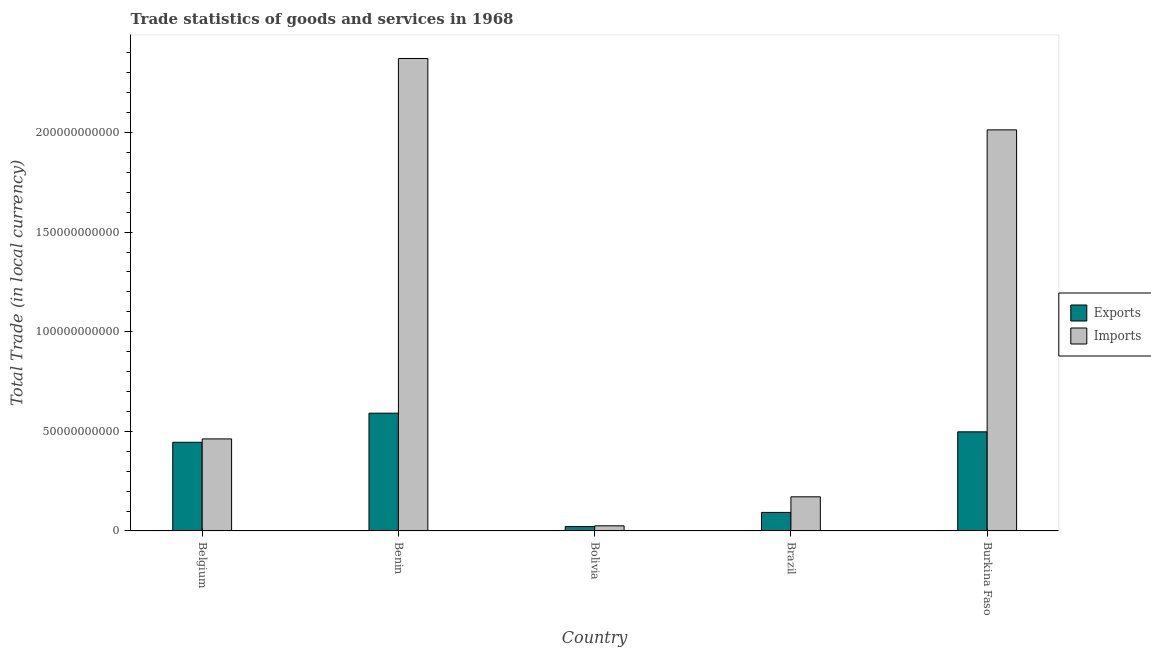How many groups of bars are there?
Give a very brief answer. 5. Are the number of bars per tick equal to the number of legend labels?
Your response must be concise. Yes. Are the number of bars on each tick of the X-axis equal?
Your response must be concise. Yes. How many bars are there on the 1st tick from the right?
Ensure brevity in your answer.  2. What is the label of the 5th group of bars from the left?
Your answer should be very brief. Burkina Faso. In how many cases, is the number of bars for a given country not equal to the number of legend labels?
Give a very brief answer. 0. What is the export of goods and services in Belgium?
Keep it short and to the point. 4.45e+1. Across all countries, what is the maximum imports of goods and services?
Make the answer very short. 2.37e+11. Across all countries, what is the minimum imports of goods and services?
Provide a short and direct response. 2.57e+09. In which country was the export of goods and services maximum?
Provide a succinct answer. Benin. In which country was the imports of goods and services minimum?
Provide a succinct answer. Bolivia. What is the total export of goods and services in the graph?
Give a very brief answer. 1.65e+11. What is the difference between the export of goods and services in Benin and that in Burkina Faso?
Provide a succinct answer. 9.37e+09. What is the difference between the export of goods and services in Brazil and the imports of goods and services in Belgium?
Provide a short and direct response. -3.69e+1. What is the average export of goods and services per country?
Keep it short and to the point. 3.30e+1. What is the difference between the export of goods and services and imports of goods and services in Bolivia?
Your answer should be very brief. -3.64e+08. What is the ratio of the imports of goods and services in Benin to that in Brazil?
Give a very brief answer. 13.84. Is the export of goods and services in Bolivia less than that in Burkina Faso?
Give a very brief answer. Yes. What is the difference between the highest and the second highest export of goods and services?
Provide a short and direct response. 9.37e+09. What is the difference between the highest and the lowest imports of goods and services?
Your answer should be compact. 2.35e+11. Is the sum of the imports of goods and services in Belgium and Burkina Faso greater than the maximum export of goods and services across all countries?
Your response must be concise. Yes. What does the 2nd bar from the left in Benin represents?
Provide a succinct answer. Imports. What does the 1st bar from the right in Burkina Faso represents?
Give a very brief answer. Imports. How many bars are there?
Give a very brief answer. 10. Are all the bars in the graph horizontal?
Provide a short and direct response. No. How many countries are there in the graph?
Ensure brevity in your answer.  5. What is the difference between two consecutive major ticks on the Y-axis?
Provide a short and direct response. 5.00e+1. Are the values on the major ticks of Y-axis written in scientific E-notation?
Your answer should be very brief. No. Does the graph contain grids?
Keep it short and to the point. No. How many legend labels are there?
Provide a short and direct response. 2. How are the legend labels stacked?
Provide a succinct answer. Vertical. What is the title of the graph?
Keep it short and to the point. Trade statistics of goods and services in 1968. What is the label or title of the X-axis?
Make the answer very short. Country. What is the label or title of the Y-axis?
Keep it short and to the point. Total Trade (in local currency). What is the Total Trade (in local currency) of Exports in Belgium?
Give a very brief answer. 4.45e+1. What is the Total Trade (in local currency) in Imports in Belgium?
Provide a succinct answer. 4.62e+1. What is the Total Trade (in local currency) in Exports in Benin?
Ensure brevity in your answer.  5.91e+1. What is the Total Trade (in local currency) of Imports in Benin?
Your response must be concise. 2.37e+11. What is the Total Trade (in local currency) in Exports in Bolivia?
Offer a very short reply. 2.20e+09. What is the Total Trade (in local currency) of Imports in Bolivia?
Offer a very short reply. 2.57e+09. What is the Total Trade (in local currency) in Exports in Brazil?
Offer a very short reply. 9.30e+09. What is the Total Trade (in local currency) of Imports in Brazil?
Provide a short and direct response. 1.71e+1. What is the Total Trade (in local currency) in Exports in Burkina Faso?
Your answer should be compact. 4.97e+1. What is the Total Trade (in local currency) in Imports in Burkina Faso?
Ensure brevity in your answer.  2.01e+11. Across all countries, what is the maximum Total Trade (in local currency) in Exports?
Offer a terse response. 5.91e+1. Across all countries, what is the maximum Total Trade (in local currency) in Imports?
Ensure brevity in your answer.  2.37e+11. Across all countries, what is the minimum Total Trade (in local currency) in Exports?
Your response must be concise. 2.20e+09. Across all countries, what is the minimum Total Trade (in local currency) of Imports?
Your answer should be compact. 2.57e+09. What is the total Total Trade (in local currency) of Exports in the graph?
Give a very brief answer. 1.65e+11. What is the total Total Trade (in local currency) of Imports in the graph?
Offer a terse response. 5.04e+11. What is the difference between the Total Trade (in local currency) in Exports in Belgium and that in Benin?
Offer a very short reply. -1.46e+1. What is the difference between the Total Trade (in local currency) of Imports in Belgium and that in Benin?
Offer a terse response. -1.91e+11. What is the difference between the Total Trade (in local currency) in Exports in Belgium and that in Bolivia?
Ensure brevity in your answer.  4.23e+1. What is the difference between the Total Trade (in local currency) in Imports in Belgium and that in Bolivia?
Your answer should be very brief. 4.36e+1. What is the difference between the Total Trade (in local currency) in Exports in Belgium and that in Brazil?
Make the answer very short. 3.52e+1. What is the difference between the Total Trade (in local currency) in Imports in Belgium and that in Brazil?
Your answer should be very brief. 2.91e+1. What is the difference between the Total Trade (in local currency) of Exports in Belgium and that in Burkina Faso?
Provide a succinct answer. -5.25e+09. What is the difference between the Total Trade (in local currency) in Imports in Belgium and that in Burkina Faso?
Ensure brevity in your answer.  -1.55e+11. What is the difference between the Total Trade (in local currency) of Exports in Benin and that in Bolivia?
Your answer should be compact. 5.69e+1. What is the difference between the Total Trade (in local currency) in Imports in Benin and that in Bolivia?
Provide a short and direct response. 2.35e+11. What is the difference between the Total Trade (in local currency) in Exports in Benin and that in Brazil?
Provide a succinct answer. 4.98e+1. What is the difference between the Total Trade (in local currency) of Imports in Benin and that in Brazil?
Keep it short and to the point. 2.20e+11. What is the difference between the Total Trade (in local currency) in Exports in Benin and that in Burkina Faso?
Provide a short and direct response. 9.37e+09. What is the difference between the Total Trade (in local currency) in Imports in Benin and that in Burkina Faso?
Make the answer very short. 3.58e+1. What is the difference between the Total Trade (in local currency) of Exports in Bolivia and that in Brazil?
Offer a terse response. -7.09e+09. What is the difference between the Total Trade (in local currency) of Imports in Bolivia and that in Brazil?
Provide a short and direct response. -1.46e+1. What is the difference between the Total Trade (in local currency) of Exports in Bolivia and that in Burkina Faso?
Make the answer very short. -4.75e+1. What is the difference between the Total Trade (in local currency) in Imports in Bolivia and that in Burkina Faso?
Provide a succinct answer. -1.99e+11. What is the difference between the Total Trade (in local currency) in Exports in Brazil and that in Burkina Faso?
Your answer should be compact. -4.05e+1. What is the difference between the Total Trade (in local currency) in Imports in Brazil and that in Burkina Faso?
Provide a short and direct response. -1.84e+11. What is the difference between the Total Trade (in local currency) in Exports in Belgium and the Total Trade (in local currency) in Imports in Benin?
Your answer should be very brief. -1.93e+11. What is the difference between the Total Trade (in local currency) in Exports in Belgium and the Total Trade (in local currency) in Imports in Bolivia?
Keep it short and to the point. 4.19e+1. What is the difference between the Total Trade (in local currency) in Exports in Belgium and the Total Trade (in local currency) in Imports in Brazil?
Ensure brevity in your answer.  2.74e+1. What is the difference between the Total Trade (in local currency) in Exports in Belgium and the Total Trade (in local currency) in Imports in Burkina Faso?
Provide a succinct answer. -1.57e+11. What is the difference between the Total Trade (in local currency) in Exports in Benin and the Total Trade (in local currency) in Imports in Bolivia?
Give a very brief answer. 5.66e+1. What is the difference between the Total Trade (in local currency) of Exports in Benin and the Total Trade (in local currency) of Imports in Brazil?
Offer a very short reply. 4.20e+1. What is the difference between the Total Trade (in local currency) of Exports in Benin and the Total Trade (in local currency) of Imports in Burkina Faso?
Give a very brief answer. -1.42e+11. What is the difference between the Total Trade (in local currency) in Exports in Bolivia and the Total Trade (in local currency) in Imports in Brazil?
Your answer should be very brief. -1.49e+1. What is the difference between the Total Trade (in local currency) in Exports in Bolivia and the Total Trade (in local currency) in Imports in Burkina Faso?
Make the answer very short. -1.99e+11. What is the difference between the Total Trade (in local currency) of Exports in Brazil and the Total Trade (in local currency) of Imports in Burkina Faso?
Offer a terse response. -1.92e+11. What is the average Total Trade (in local currency) in Exports per country?
Provide a short and direct response. 3.30e+1. What is the average Total Trade (in local currency) in Imports per country?
Provide a succinct answer. 1.01e+11. What is the difference between the Total Trade (in local currency) in Exports and Total Trade (in local currency) in Imports in Belgium?
Your response must be concise. -1.69e+09. What is the difference between the Total Trade (in local currency) in Exports and Total Trade (in local currency) in Imports in Benin?
Your answer should be compact. -1.78e+11. What is the difference between the Total Trade (in local currency) in Exports and Total Trade (in local currency) in Imports in Bolivia?
Give a very brief answer. -3.64e+08. What is the difference between the Total Trade (in local currency) of Exports and Total Trade (in local currency) of Imports in Brazil?
Offer a very short reply. -7.83e+09. What is the difference between the Total Trade (in local currency) of Exports and Total Trade (in local currency) of Imports in Burkina Faso?
Give a very brief answer. -1.52e+11. What is the ratio of the Total Trade (in local currency) of Exports in Belgium to that in Benin?
Make the answer very short. 0.75. What is the ratio of the Total Trade (in local currency) of Imports in Belgium to that in Benin?
Make the answer very short. 0.19. What is the ratio of the Total Trade (in local currency) of Exports in Belgium to that in Bolivia?
Give a very brief answer. 20.19. What is the ratio of the Total Trade (in local currency) of Imports in Belgium to that in Bolivia?
Make the answer very short. 17.99. What is the ratio of the Total Trade (in local currency) in Exports in Belgium to that in Brazil?
Offer a very short reply. 4.79. What is the ratio of the Total Trade (in local currency) in Imports in Belgium to that in Brazil?
Make the answer very short. 2.7. What is the ratio of the Total Trade (in local currency) in Exports in Belgium to that in Burkina Faso?
Offer a terse response. 0.89. What is the ratio of the Total Trade (in local currency) in Imports in Belgium to that in Burkina Faso?
Ensure brevity in your answer.  0.23. What is the ratio of the Total Trade (in local currency) of Exports in Benin to that in Bolivia?
Offer a terse response. 26.82. What is the ratio of the Total Trade (in local currency) in Imports in Benin to that in Bolivia?
Your response must be concise. 92.37. What is the ratio of the Total Trade (in local currency) of Exports in Benin to that in Brazil?
Offer a very short reply. 6.36. What is the ratio of the Total Trade (in local currency) in Imports in Benin to that in Brazil?
Offer a very short reply. 13.84. What is the ratio of the Total Trade (in local currency) of Exports in Benin to that in Burkina Faso?
Your response must be concise. 1.19. What is the ratio of the Total Trade (in local currency) of Imports in Benin to that in Burkina Faso?
Keep it short and to the point. 1.18. What is the ratio of the Total Trade (in local currency) in Exports in Bolivia to that in Brazil?
Your response must be concise. 0.24. What is the ratio of the Total Trade (in local currency) of Imports in Bolivia to that in Brazil?
Provide a short and direct response. 0.15. What is the ratio of the Total Trade (in local currency) of Exports in Bolivia to that in Burkina Faso?
Give a very brief answer. 0.04. What is the ratio of the Total Trade (in local currency) in Imports in Bolivia to that in Burkina Faso?
Provide a succinct answer. 0.01. What is the ratio of the Total Trade (in local currency) of Exports in Brazil to that in Burkina Faso?
Make the answer very short. 0.19. What is the ratio of the Total Trade (in local currency) in Imports in Brazil to that in Burkina Faso?
Ensure brevity in your answer.  0.09. What is the difference between the highest and the second highest Total Trade (in local currency) in Exports?
Make the answer very short. 9.37e+09. What is the difference between the highest and the second highest Total Trade (in local currency) of Imports?
Give a very brief answer. 3.58e+1. What is the difference between the highest and the lowest Total Trade (in local currency) of Exports?
Give a very brief answer. 5.69e+1. What is the difference between the highest and the lowest Total Trade (in local currency) of Imports?
Your answer should be compact. 2.35e+11. 